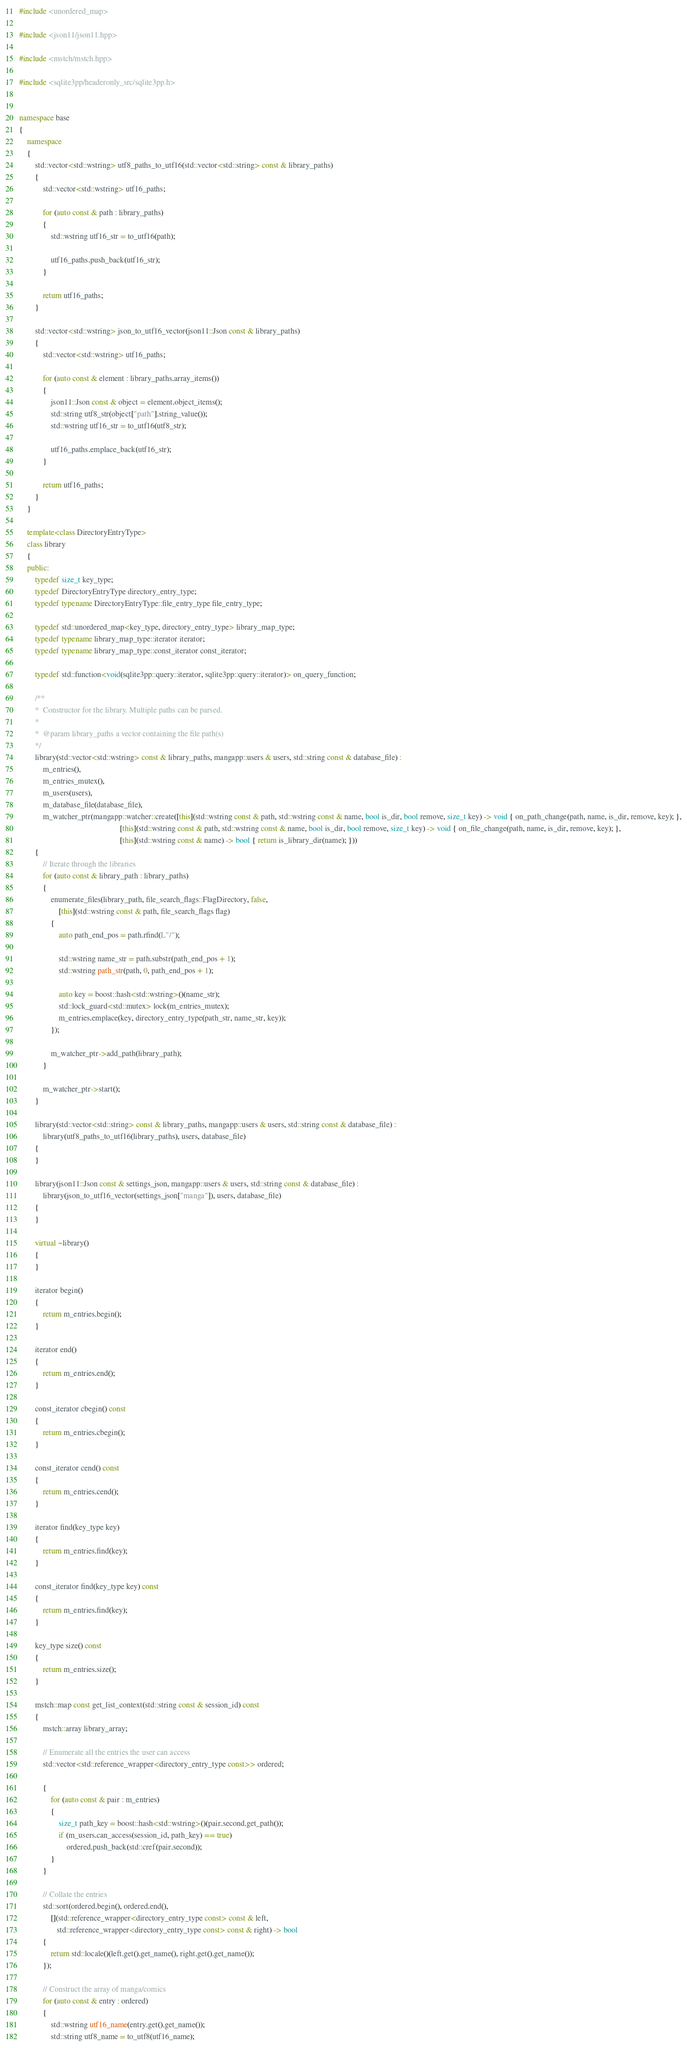<code> <loc_0><loc_0><loc_500><loc_500><_C++_>#include <unordered_map>

#include <json11/json11.hpp>

#include <mstch/mstch.hpp>

#include <sqlite3pp/headeronly_src/sqlite3pp.h>


namespace base
{
    namespace
    {
        std::vector<std::wstring> utf8_paths_to_utf16(std::vector<std::string> const & library_paths)
        {
            std::vector<std::wstring> utf16_paths;

            for (auto const & path : library_paths)
            {
                std::wstring utf16_str = to_utf16(path);

                utf16_paths.push_back(utf16_str);
            }

            return utf16_paths;
        }

        std::vector<std::wstring> json_to_utf16_vector(json11::Json const & library_paths)
        {
            std::vector<std::wstring> utf16_paths;

            for (auto const & element : library_paths.array_items())
            {
                json11::Json const & object = element.object_items();
                std::string utf8_str(object["path"].string_value());
                std::wstring utf16_str = to_utf16(utf8_str);

                utf16_paths.emplace_back(utf16_str);
            }

            return utf16_paths;
        }
    }

    template<class DirectoryEntryType>
    class library
    {
    public:
        typedef size_t key_type;
        typedef DirectoryEntryType directory_entry_type;
        typedef typename DirectoryEntryType::file_entry_type file_entry_type;

        typedef std::unordered_map<key_type, directory_entry_type> library_map_type;
        typedef typename library_map_type::iterator iterator;
        typedef typename library_map_type::const_iterator const_iterator;

        typedef std::function<void(sqlite3pp::query::iterator, sqlite3pp::query::iterator)> on_query_function;

        /**
        *  Constructor for the library. Multiple paths can be parsed.
        *
        *  @param library_paths a vector containing the file path(s)
        */
        library(std::vector<std::wstring> const & library_paths, mangapp::users & users, std::string const & database_file) :
            m_entries(),
            m_entries_mutex(),
            m_users(users),
            m_database_file(database_file),
            m_watcher_ptr(mangapp::watcher::create([this](std::wstring const & path, std::wstring const & name, bool is_dir, bool remove, size_t key) -> void { on_path_change(path, name, is_dir, remove, key); },
                                                   [this](std::wstring const & path, std::wstring const & name, bool is_dir, bool remove, size_t key) -> void { on_file_change(path, name, is_dir, remove, key); },
                                                   [this](std::wstring const & name) -> bool { return is_library_dir(name); }))
        {
            // Iterate through the libraries
            for (auto const & library_path : library_paths)
            {
                enumerate_files(library_path, file_search_flags::FlagDirectory, false,
                    [this](std::wstring const & path, file_search_flags flag)
                {
                    auto path_end_pos = path.rfind(L"/");

                    std::wstring name_str = path.substr(path_end_pos + 1);
                    std::wstring path_str(path, 0, path_end_pos + 1);

                    auto key = boost::hash<std::wstring>()(name_str);
                    std::lock_guard<std::mutex> lock(m_entries_mutex);
                    m_entries.emplace(key, directory_entry_type(path_str, name_str, key));
                });

                m_watcher_ptr->add_path(library_path);
            }

            m_watcher_ptr->start();
        }

        library(std::vector<std::string> const & library_paths, mangapp::users & users, std::string const & database_file) :
            library(utf8_paths_to_utf16(library_paths), users, database_file)
        {
        }

        library(json11::Json const & settings_json, mangapp::users & users, std::string const & database_file) :
            library(json_to_utf16_vector(settings_json["manga"]), users, database_file)
        {
        }

        virtual ~library()
        {
        }

        iterator begin()
        {
            return m_entries.begin();
        }

        iterator end()
        {
            return m_entries.end();
        }

        const_iterator cbegin() const
        {
            return m_entries.cbegin();
        }

        const_iterator cend() const
        {
            return m_entries.cend();
        }

        iterator find(key_type key)
        {
            return m_entries.find(key);
        }

        const_iterator find(key_type key) const
        {
            return m_entries.find(key);
        }

        key_type size() const
        {
            return m_entries.size();
        }

        mstch::map const get_list_context(std::string const & session_id) const
        {
            mstch::array library_array;

            // Enumerate all the entries the user can access
            std::vector<std::reference_wrapper<directory_entry_type const>> ordered;

            {
                for (auto const & pair : m_entries)
                {
                    size_t path_key = boost::hash<std::wstring>()(pair.second.get_path());
                    if (m_users.can_access(session_id, path_key) == true)
                        ordered.push_back(std::cref(pair.second));
                }
            }

            // Collate the entries
            std::sort(ordered.begin(), ordered.end(),
                [](std::reference_wrapper<directory_entry_type const> const & left,
                   std::reference_wrapper<directory_entry_type const> const & right) -> bool
            {
                return std::locale()(left.get().get_name(), right.get().get_name());
            });

            // Construct the array of manga/comics
            for (auto const & entry : ordered)
            {
                std::wstring utf16_name(entry.get().get_name());
                std::string utf8_name = to_utf8(utf16_name);
</code> 